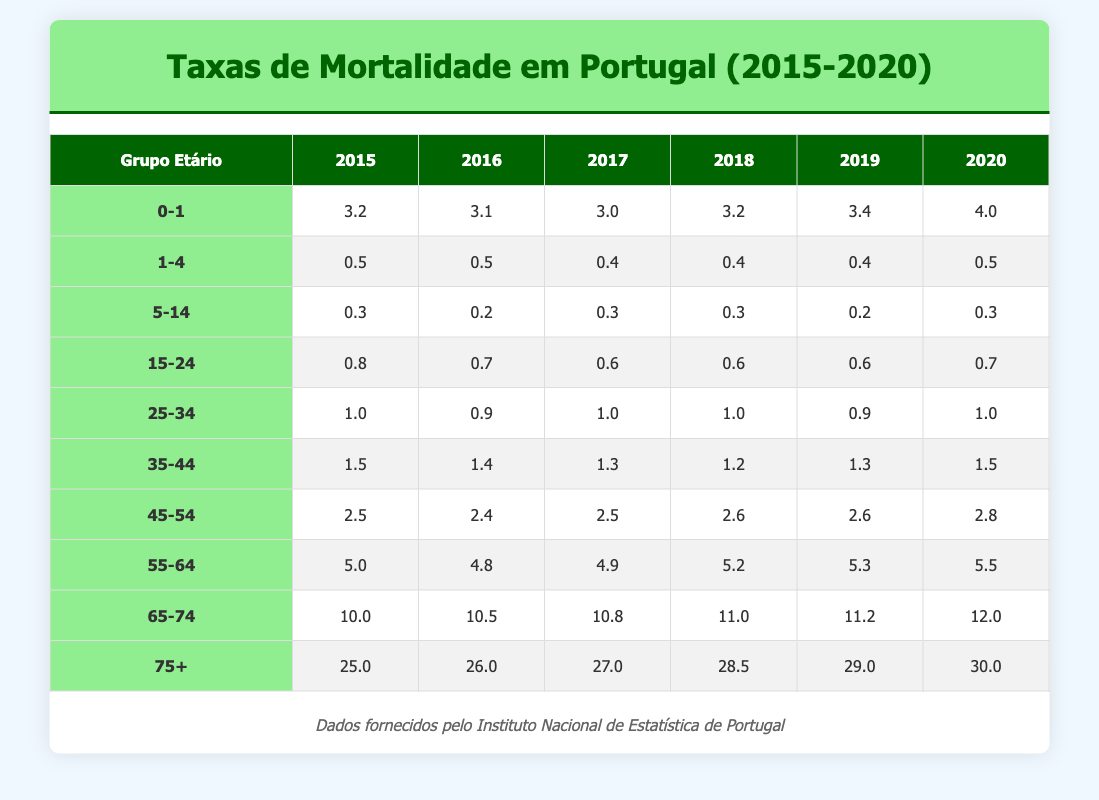What was the mortality rate for the age group 0-1 in 2017? Looking at the table, under the age group 0-1 for the year 2017, the rate is listed as 3.0.
Answer: 3.0 What was the highest mortality rate recorded in the age group 65-74 from 2015 to 2020? In the table for the age group 65-74, the rates across the years are 10.0, 10.5, 10.8, 11.0, 11.2, and 12.0. The highest rate is 12.0 in 2020.
Answer: 12.0 What is the average mortality rate for the age group 45-54 over the years 2015 to 2020? The rates for 2015 to 2020 in the age group 45-54 are 2.5, 2.4, 2.5, 2.6, 2.6, and 2.8. Summing these values gives 15.4, and dividing by 6 (the number of years) results in an average of 2.5667, which rounds to 2.6.
Answer: 2.6 Is the mortality rate for the age group 1-4 higher in 2020 compared to 2015? The table shows a mortality rate of 0.5 for the age group 1-4 in both 2015 and 2020. Therefore, the statement is false as they are equal.
Answer: No Which age group experienced the largest increase in mortality rate from 2015 to 2020? Analyzing the data, the age group 75+ had a mortality rate increase from 25.0 in 2015 to 30.0 in 2020, yielding an increase of 5.0. This is greater than any other age group's increase over that time period.
Answer: 75+ What was the trend for the mortality rates in the age group 55-64 from 2015 to 2020? The rates for the age group 55-64 are listed as 5.0, 4.8, 4.9, 5.2, 5.3, and 5.5 across the years. Analyzing these values shows a general upward trend, increasing from 4.8 in 2016 to 5.5 in 2020.
Answer: Upward Was there any year in which the mortality rate for the age group 25-34 decreased from the previous year? Checking the year-over-year changes for the age group 25-34, in 2015 it was 1.0, in 2016 it decreased to 0.9. Thus, the answer is yes, there was a decrease in 2016.
Answer: Yes What is the difference in mortality rate between the age groups 0-1 and 75+ in 2020? In 2020, the rate for age group 0-1 is 4.0 and for 75+ it is 30.0. The difference is calculated as 30.0 - 4.0, which equals 26.0.
Answer: 26.0 